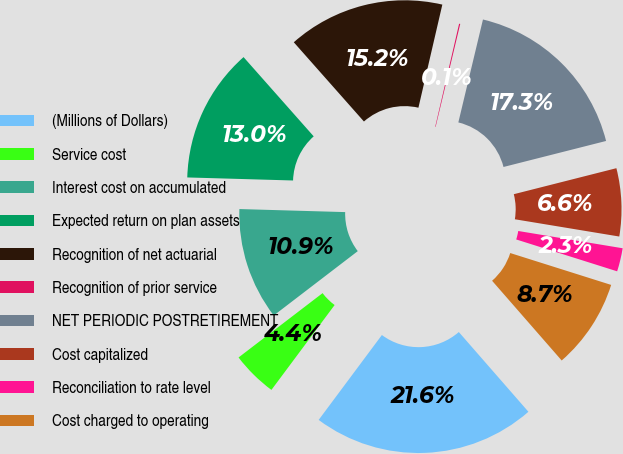Convert chart to OTSL. <chart><loc_0><loc_0><loc_500><loc_500><pie_chart><fcel>(Millions of Dollars)<fcel>Service cost<fcel>Interest cost on accumulated<fcel>Expected return on plan assets<fcel>Recognition of net actuarial<fcel>Recognition of prior service<fcel>NET PERIODIC POSTRETIREMENT<fcel>Cost capitalized<fcel>Reconciliation to rate level<fcel>Cost charged to operating<nl><fcel>21.61%<fcel>4.41%<fcel>10.86%<fcel>13.01%<fcel>15.16%<fcel>0.11%<fcel>17.31%<fcel>6.56%<fcel>2.26%<fcel>8.71%<nl></chart> 